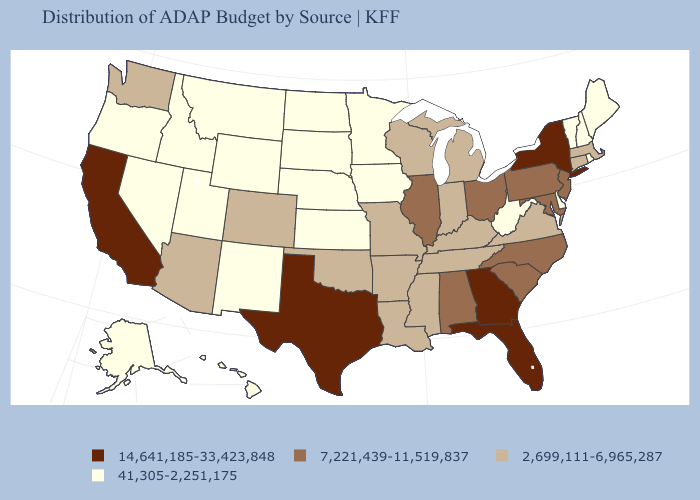Does Texas have the highest value in the USA?
Give a very brief answer. Yes. What is the lowest value in the Northeast?
Be succinct. 41,305-2,251,175. Among the states that border South Carolina , does Georgia have the highest value?
Be succinct. Yes. What is the value of Oregon?
Give a very brief answer. 41,305-2,251,175. Does the map have missing data?
Keep it brief. No. What is the highest value in states that border Michigan?
Give a very brief answer. 7,221,439-11,519,837. What is the value of Nevada?
Answer briefly. 41,305-2,251,175. Does Missouri have the lowest value in the MidWest?
Be succinct. No. Does Michigan have a lower value than Vermont?
Write a very short answer. No. What is the lowest value in the MidWest?
Be succinct. 41,305-2,251,175. What is the lowest value in the USA?
Short answer required. 41,305-2,251,175. What is the value of Oregon?
Answer briefly. 41,305-2,251,175. What is the lowest value in the USA?
Answer briefly. 41,305-2,251,175. What is the highest value in states that border Idaho?
Be succinct. 2,699,111-6,965,287. Among the states that border Georgia , which have the highest value?
Answer briefly. Florida. 